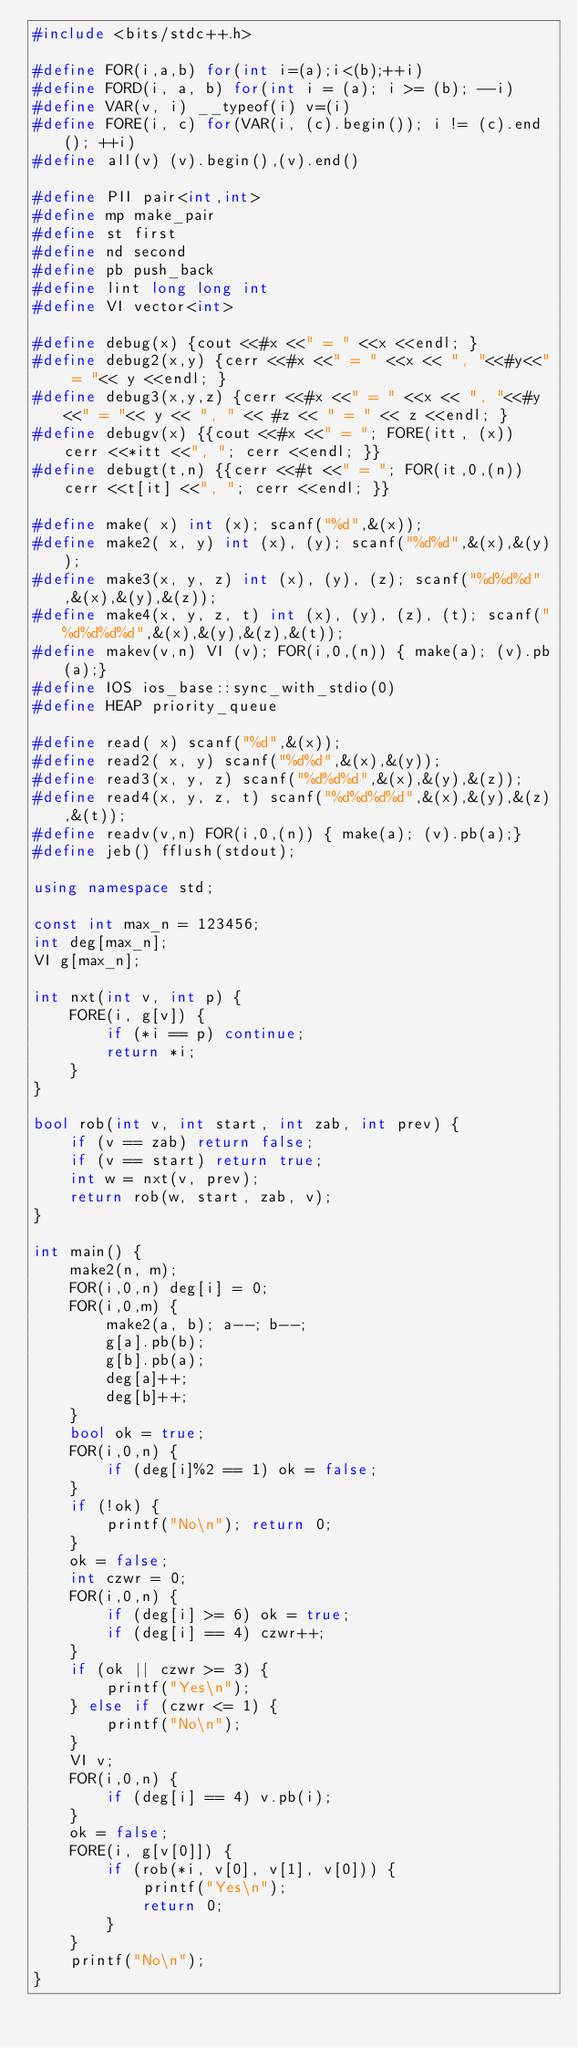Convert code to text. <code><loc_0><loc_0><loc_500><loc_500><_C++_>#include <bits/stdc++.h>

#define FOR(i,a,b) for(int i=(a);i<(b);++i)
#define FORD(i, a, b) for(int i = (a); i >= (b); --i)
#define VAR(v, i) __typeof(i) v=(i)
#define FORE(i, c) for(VAR(i, (c).begin()); i != (c).end(); ++i)
#define all(v) (v).begin(),(v).end()

#define PII pair<int,int>
#define mp make_pair
#define st first
#define nd second
#define pb push_back
#define lint long long int
#define VI vector<int>

#define debug(x) {cout <<#x <<" = " <<x <<endl; }
#define debug2(x,y) {cerr <<#x <<" = " <<x << ", "<<#y<<" = "<< y <<endl; } 
#define debug3(x,y,z) {cerr <<#x <<" = " <<x << ", "<<#y<<" = "<< y << ", " << #z << " = " << z <<endl; } 
#define debugv(x) {{cout <<#x <<" = "; FORE(itt, (x)) cerr <<*itt <<", "; cerr <<endl; }}
#define debugt(t,n) {{cerr <<#t <<" = "; FOR(it,0,(n)) cerr <<t[it] <<", "; cerr <<endl; }}

#define make( x) int (x); scanf("%d",&(x));
#define make2( x, y) int (x), (y); scanf("%d%d",&(x),&(y));
#define make3(x, y, z) int (x), (y), (z); scanf("%d%d%d",&(x),&(y),&(z));
#define make4(x, y, z, t) int (x), (y), (z), (t); scanf("%d%d%d%d",&(x),&(y),&(z),&(t));
#define makev(v,n) VI (v); FOR(i,0,(n)) { make(a); (v).pb(a);} 
#define IOS ios_base::sync_with_stdio(0)
#define HEAP priority_queue

#define read( x) scanf("%d",&(x));
#define read2( x, y) scanf("%d%d",&(x),&(y));
#define read3(x, y, z) scanf("%d%d%d",&(x),&(y),&(z));
#define read4(x, y, z, t) scanf("%d%d%d%d",&(x),&(y),&(z),&(t));
#define readv(v,n) FOR(i,0,(n)) { make(a); (v).pb(a);}
#define jeb() fflush(stdout);

using namespace std;

const int max_n = 123456;
int deg[max_n];
VI g[max_n];

int nxt(int v, int p) {
	FORE(i, g[v]) {
		if (*i == p) continue;
		return *i;
	}
}

bool rob(int v, int start, int zab, int prev) {
	if (v == zab) return false;
	if (v == start) return true;
	int w = nxt(v, prev);
	return rob(w, start, zab, v);
}

int main() {
	make2(n, m);
	FOR(i,0,n) deg[i] = 0;
	FOR(i,0,m) {
		make2(a, b); a--; b--;
		g[a].pb(b);
		g[b].pb(a);
		deg[a]++;
		deg[b]++;
	}
	bool ok = true;
	FOR(i,0,n) {
		if (deg[i]%2 == 1) ok = false;
	}
	if (!ok) {
		printf("No\n"); return 0;
	}
	ok = false;
	int czwr = 0;
	FOR(i,0,n) {
		if (deg[i] >= 6) ok = true;
		if (deg[i] == 4) czwr++;
	}
	if (ok || czwr >= 3) {
		printf("Yes\n");
	} else if (czwr <= 1) {
		printf("No\n");
	}
	VI v;
	FOR(i,0,n) {
		if (deg[i] == 4) v.pb(i);
	}
	ok = false;
	FORE(i, g[v[0]]) {
		if (rob(*i, v[0], v[1], v[0])) {
			printf("Yes\n");
			return 0;
		} 
	}
	printf("No\n");
}




</code> 